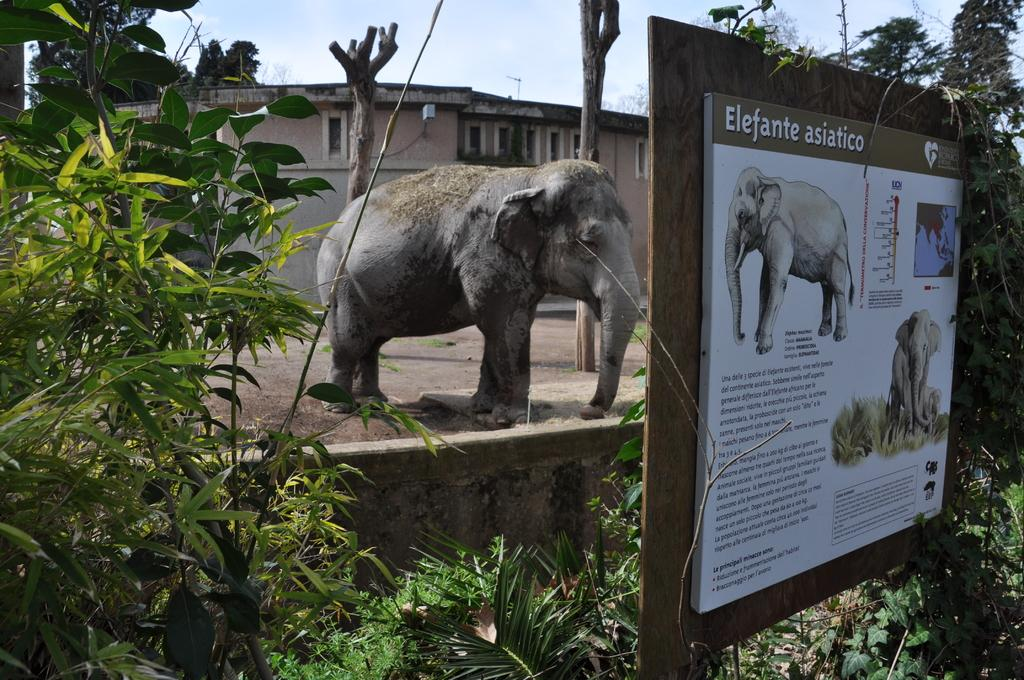What is the main object in the foreground of the image? There is a notice board in the image. What can be seen beside the notice board? There are trees beside the notice board. What is visible in the background of the image? There is an elephant and a building in the background of the image. What type of hair is visible on the elephant in the image? There is no hair visible on the elephant in the image, as elephants have bristly hair and not the type of hair typically referred to in this context. 